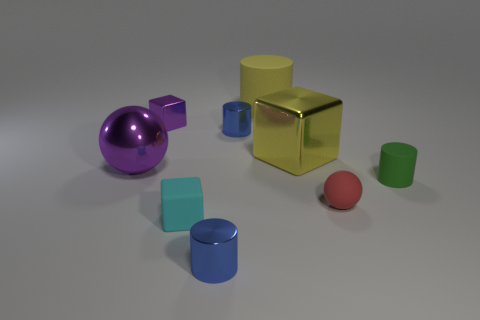Do the tiny green cylinder and the small blue cylinder that is behind the yellow cube have the same material?
Your answer should be very brief. No. What is the material of the other object that is the same shape as the red matte object?
Your answer should be very brief. Metal. Do the yellow cylinder and the big block have the same material?
Give a very brief answer. No. What is the blue object that is behind the green matte cylinder made of?
Give a very brief answer. Metal. How many cylinders are both on the left side of the red ball and behind the small cyan rubber block?
Offer a very short reply. 2. The large block is what color?
Offer a terse response. Yellow. Is there a block that has the same material as the purple ball?
Provide a short and direct response. Yes. There is a ball to the right of the blue cylinder that is behind the purple shiny ball; are there any tiny green things that are in front of it?
Your answer should be compact. No. There is a cyan matte object; are there any blue things behind it?
Give a very brief answer. Yes. Are there any large shiny blocks that have the same color as the rubber cube?
Make the answer very short. No. 